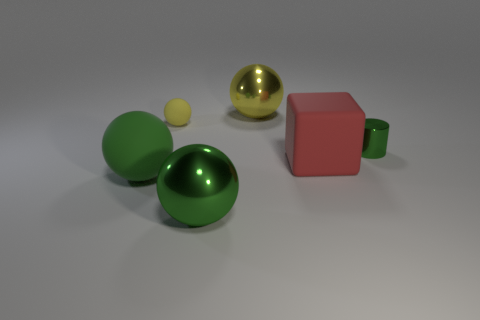Subtract all purple balls. Subtract all red cubes. How many balls are left? 4 Add 2 large red objects. How many objects exist? 8 Subtract all cylinders. How many objects are left? 5 Subtract 0 blue balls. How many objects are left? 6 Subtract all small spheres. Subtract all balls. How many objects are left? 1 Add 2 red matte blocks. How many red matte blocks are left? 3 Add 1 small yellow matte things. How many small yellow matte things exist? 2 